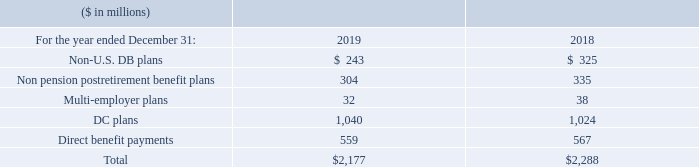Contributions and Direct Benefit Payments
It is the company’s general practice to fund amounts for pensions sufficient to meet the minimum requirements set forth in applicable employee benefits laws and local tax laws. From time to time, the company contributes additional amounts as it deems appropriate.
The following table presents the contributions made to the non-U.S. DB plans, non pension postretirement benefit plans, multi-employer plans, DC plans and direct payments for 2019 and 2018. The cash contributions to the multi-employer plans represent the annual cost included in the net periodic (income)/ cost recognized in the Consolidated Income Statement. The company’s participation in multi-employer plans has no material impact on the company’s financial statements.
In 2019 and 2018, $635 million and $598 million, respectively, was contributed in U.S. Treasury securities, which is considered a non-cash transaction (includes the Active Medical Trust).
In 2019, what was the amount contributed to US Treasury securities? $635 million. Contribution to US Treasury is considered what kind of a transaction? Non-cash transaction. What was the Non pension post retirement benefit plan in 2019?
Answer scale should be: million. 304. What is the increase / (decrease) in the Non-U.S. DB plans from 2018 to 2019?
Answer scale should be: million. 243 - 325
Answer: -82. What is the average Non pension postretirement benefit plans?
Answer scale should be: million. (304 + 335) / 2
Answer: 319.5. What is the percentage increase / (decrease) in the Direct benefit payments from 2018 to 2019?
Answer scale should be: percent. 559 / 567 - 1
Answer: -1.41. 